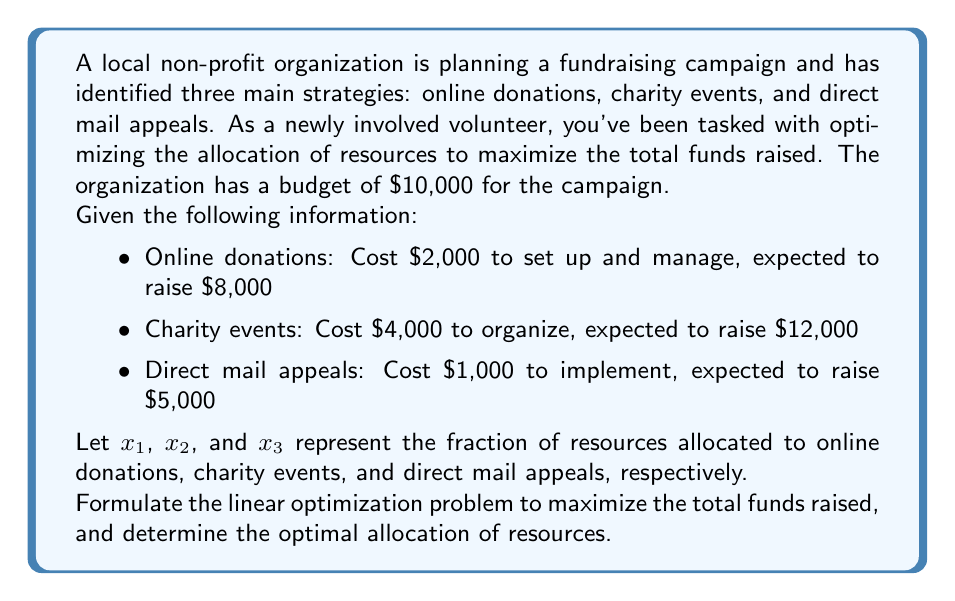Teach me how to tackle this problem. To solve this problem, we need to set up a linear programming model and then solve it. Let's go through this step-by-step:

1) First, let's define our objective function. We want to maximize the total funds raised:

   Maximize: $Z = 8000x_1 + 12000x_2 + 5000x_3$

2) Now, we need to set up our constraints:

   a) Budget constraint: The total cost cannot exceed $10,000
      $2000x_1 + 4000x_2 + 1000x_3 \leq 10000$

   b) Allocation constraints: The sum of all fractions must equal 1
      $x_1 + x_2 + x_3 = 1$

   c) Non-negativity constraints:
      $x_1 \geq 0, x_2 \geq 0, x_3 \geq 0$

3) Now we have our complete linear programming model:

   Maximize: $Z = 8000x_1 + 12000x_2 + 5000x_3$
   Subject to:
   $2000x_1 + 4000x_2 + 1000x_3 \leq 10000$
   $x_1 + x_2 + x_3 = 1$
   $x_1 \geq 0, x_2 \geq 0, x_3 \geq 0$

4) To solve this, we can use the simplex method or a linear programming solver. However, we can also solve this problem by observation:

   - Charity events have the highest return on investment (ROI): $12000/4000 = 3$
   - Online donations have the second highest ROI: $8000/2000 = 4$
   - Direct mail appeals have the lowest ROI: $5000/1000 = 5$

5) The optimal solution would be to allocate as much as possible to charity events, then to online donations, and finally to direct mail appeals if there's any budget left.

6) We can allocate $8000 to charity events ($x_2 = 0.8$), which leaves $2000 for online donations ($x_1 = 0.2$), and nothing for direct mail appeals ($x_3 = 0$).

7) Let's verify this solution:
   - Cost: $4000(0.8) + 2000(0.2) + 1000(0) = 3200 + 400 = 3600 \leq 10000$
   - Allocation sum: $0.8 + 0.2 + 0 = 1$

8) The total funds raised with this allocation would be:
   $Z = 8000(0.2) + 12000(0.8) + 5000(0) = 1600 + 9600 = 11200$
Answer: The optimal allocation of resources is:
$x_1 = 0.2$ (Online donations)
$x_2 = 0.8$ (Charity events)
$x_3 = 0$ (Direct mail appeals)

This allocation will maximize the total funds raised to $11,200. 